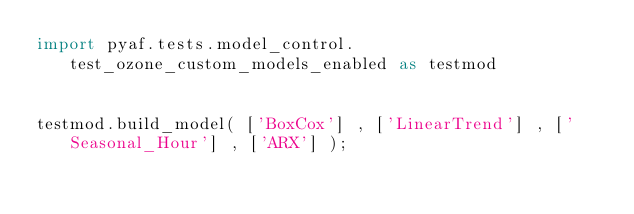<code> <loc_0><loc_0><loc_500><loc_500><_Python_>import pyaf.tests.model_control.test_ozone_custom_models_enabled as testmod


testmod.build_model( ['BoxCox'] , ['LinearTrend'] , ['Seasonal_Hour'] , ['ARX'] );</code> 